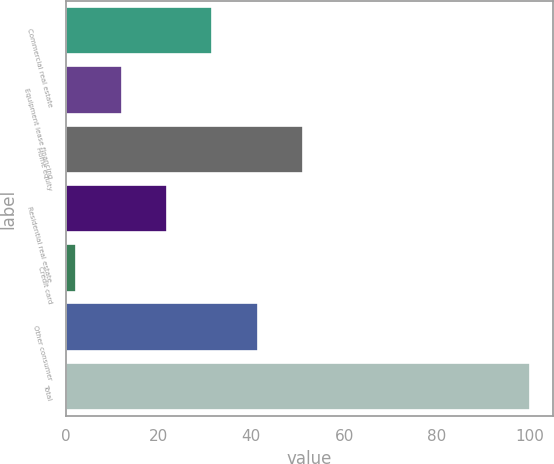Convert chart to OTSL. <chart><loc_0><loc_0><loc_500><loc_500><bar_chart><fcel>Commercial real estate<fcel>Equipment lease financing<fcel>Home equity<fcel>Residential real estate<fcel>Credit card<fcel>Other consumer<fcel>Total<nl><fcel>31.61<fcel>12.07<fcel>51.15<fcel>21.84<fcel>2.3<fcel>41.38<fcel>100<nl></chart> 